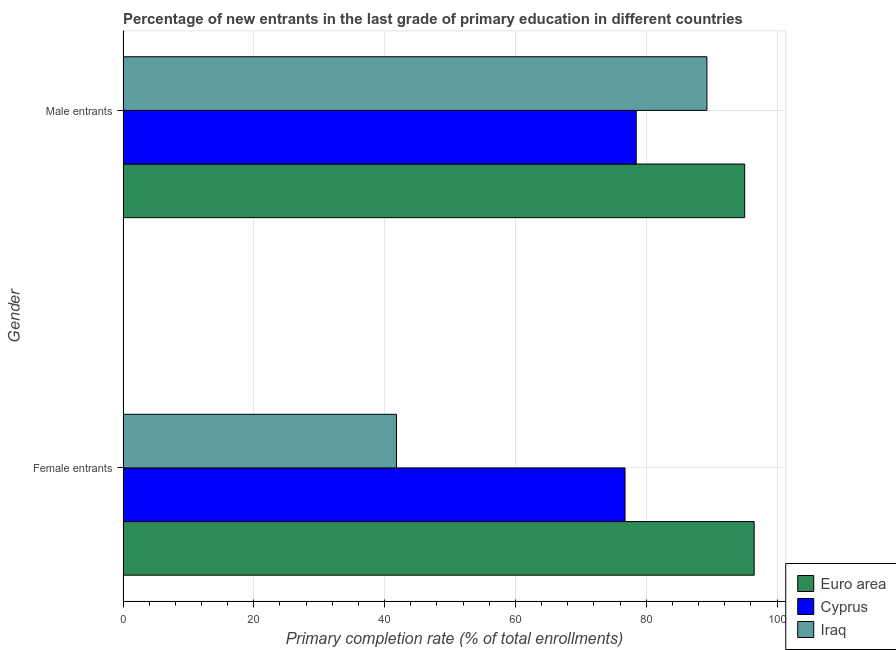How many different coloured bars are there?
Ensure brevity in your answer.  3. How many groups of bars are there?
Your response must be concise. 2. How many bars are there on the 1st tick from the top?
Keep it short and to the point. 3. What is the label of the 2nd group of bars from the top?
Provide a succinct answer. Female entrants. What is the primary completion rate of male entrants in Cyprus?
Provide a succinct answer. 78.47. Across all countries, what is the maximum primary completion rate of female entrants?
Provide a short and direct response. 96.5. Across all countries, what is the minimum primary completion rate of male entrants?
Provide a short and direct response. 78.47. In which country was the primary completion rate of female entrants minimum?
Your response must be concise. Iraq. What is the total primary completion rate of male entrants in the graph?
Your response must be concise. 262.79. What is the difference between the primary completion rate of female entrants in Iraq and that in Cyprus?
Make the answer very short. -34.94. What is the difference between the primary completion rate of female entrants in Cyprus and the primary completion rate of male entrants in Euro area?
Your answer should be very brief. -18.29. What is the average primary completion rate of female entrants per country?
Provide a succinct answer. 71.69. What is the difference between the primary completion rate of male entrants and primary completion rate of female entrants in Cyprus?
Your response must be concise. 1.71. In how many countries, is the primary completion rate of male entrants greater than 48 %?
Your response must be concise. 3. What is the ratio of the primary completion rate of female entrants in Cyprus to that in Iraq?
Offer a terse response. 1.84. In how many countries, is the primary completion rate of female entrants greater than the average primary completion rate of female entrants taken over all countries?
Offer a terse response. 2. What does the 2nd bar from the bottom in Female entrants represents?
Your response must be concise. Cyprus. How many bars are there?
Offer a terse response. 6. Are all the bars in the graph horizontal?
Make the answer very short. Yes. What is the difference between two consecutive major ticks on the X-axis?
Keep it short and to the point. 20. Are the values on the major ticks of X-axis written in scientific E-notation?
Your response must be concise. No. How many legend labels are there?
Keep it short and to the point. 3. How are the legend labels stacked?
Your answer should be very brief. Vertical. What is the title of the graph?
Your response must be concise. Percentage of new entrants in the last grade of primary education in different countries. Does "Botswana" appear as one of the legend labels in the graph?
Offer a terse response. No. What is the label or title of the X-axis?
Your response must be concise. Primary completion rate (% of total enrollments). What is the label or title of the Y-axis?
Ensure brevity in your answer.  Gender. What is the Primary completion rate (% of total enrollments) of Euro area in Female entrants?
Provide a short and direct response. 96.5. What is the Primary completion rate (% of total enrollments) in Cyprus in Female entrants?
Provide a short and direct response. 76.76. What is the Primary completion rate (% of total enrollments) of Iraq in Female entrants?
Provide a short and direct response. 41.82. What is the Primary completion rate (% of total enrollments) of Euro area in Male entrants?
Ensure brevity in your answer.  95.05. What is the Primary completion rate (% of total enrollments) in Cyprus in Male entrants?
Offer a terse response. 78.47. What is the Primary completion rate (% of total enrollments) of Iraq in Male entrants?
Ensure brevity in your answer.  89.27. Across all Gender, what is the maximum Primary completion rate (% of total enrollments) of Euro area?
Your answer should be very brief. 96.5. Across all Gender, what is the maximum Primary completion rate (% of total enrollments) in Cyprus?
Make the answer very short. 78.47. Across all Gender, what is the maximum Primary completion rate (% of total enrollments) of Iraq?
Keep it short and to the point. 89.27. Across all Gender, what is the minimum Primary completion rate (% of total enrollments) of Euro area?
Give a very brief answer. 95.05. Across all Gender, what is the minimum Primary completion rate (% of total enrollments) of Cyprus?
Offer a very short reply. 76.76. Across all Gender, what is the minimum Primary completion rate (% of total enrollments) of Iraq?
Keep it short and to the point. 41.82. What is the total Primary completion rate (% of total enrollments) in Euro area in the graph?
Your answer should be very brief. 191.55. What is the total Primary completion rate (% of total enrollments) of Cyprus in the graph?
Make the answer very short. 155.22. What is the total Primary completion rate (% of total enrollments) of Iraq in the graph?
Give a very brief answer. 131.09. What is the difference between the Primary completion rate (% of total enrollments) in Euro area in Female entrants and that in Male entrants?
Make the answer very short. 1.45. What is the difference between the Primary completion rate (% of total enrollments) in Cyprus in Female entrants and that in Male entrants?
Your answer should be very brief. -1.71. What is the difference between the Primary completion rate (% of total enrollments) in Iraq in Female entrants and that in Male entrants?
Provide a succinct answer. -47.46. What is the difference between the Primary completion rate (% of total enrollments) of Euro area in Female entrants and the Primary completion rate (% of total enrollments) of Cyprus in Male entrants?
Your answer should be very brief. 18.03. What is the difference between the Primary completion rate (% of total enrollments) in Euro area in Female entrants and the Primary completion rate (% of total enrollments) in Iraq in Male entrants?
Ensure brevity in your answer.  7.23. What is the difference between the Primary completion rate (% of total enrollments) of Cyprus in Female entrants and the Primary completion rate (% of total enrollments) of Iraq in Male entrants?
Provide a succinct answer. -12.52. What is the average Primary completion rate (% of total enrollments) of Euro area per Gender?
Offer a very short reply. 95.77. What is the average Primary completion rate (% of total enrollments) in Cyprus per Gender?
Offer a very short reply. 77.61. What is the average Primary completion rate (% of total enrollments) of Iraq per Gender?
Your answer should be compact. 65.54. What is the difference between the Primary completion rate (% of total enrollments) in Euro area and Primary completion rate (% of total enrollments) in Cyprus in Female entrants?
Your answer should be very brief. 19.74. What is the difference between the Primary completion rate (% of total enrollments) of Euro area and Primary completion rate (% of total enrollments) of Iraq in Female entrants?
Your answer should be very brief. 54.68. What is the difference between the Primary completion rate (% of total enrollments) in Cyprus and Primary completion rate (% of total enrollments) in Iraq in Female entrants?
Make the answer very short. 34.94. What is the difference between the Primary completion rate (% of total enrollments) of Euro area and Primary completion rate (% of total enrollments) of Cyprus in Male entrants?
Provide a short and direct response. 16.58. What is the difference between the Primary completion rate (% of total enrollments) of Euro area and Primary completion rate (% of total enrollments) of Iraq in Male entrants?
Offer a terse response. 5.78. What is the difference between the Primary completion rate (% of total enrollments) of Cyprus and Primary completion rate (% of total enrollments) of Iraq in Male entrants?
Make the answer very short. -10.8. What is the ratio of the Primary completion rate (% of total enrollments) of Euro area in Female entrants to that in Male entrants?
Your response must be concise. 1.02. What is the ratio of the Primary completion rate (% of total enrollments) in Cyprus in Female entrants to that in Male entrants?
Give a very brief answer. 0.98. What is the ratio of the Primary completion rate (% of total enrollments) of Iraq in Female entrants to that in Male entrants?
Offer a terse response. 0.47. What is the difference between the highest and the second highest Primary completion rate (% of total enrollments) of Euro area?
Keep it short and to the point. 1.45. What is the difference between the highest and the second highest Primary completion rate (% of total enrollments) of Cyprus?
Offer a very short reply. 1.71. What is the difference between the highest and the second highest Primary completion rate (% of total enrollments) in Iraq?
Offer a very short reply. 47.46. What is the difference between the highest and the lowest Primary completion rate (% of total enrollments) in Euro area?
Make the answer very short. 1.45. What is the difference between the highest and the lowest Primary completion rate (% of total enrollments) in Cyprus?
Your response must be concise. 1.71. What is the difference between the highest and the lowest Primary completion rate (% of total enrollments) in Iraq?
Your answer should be very brief. 47.46. 